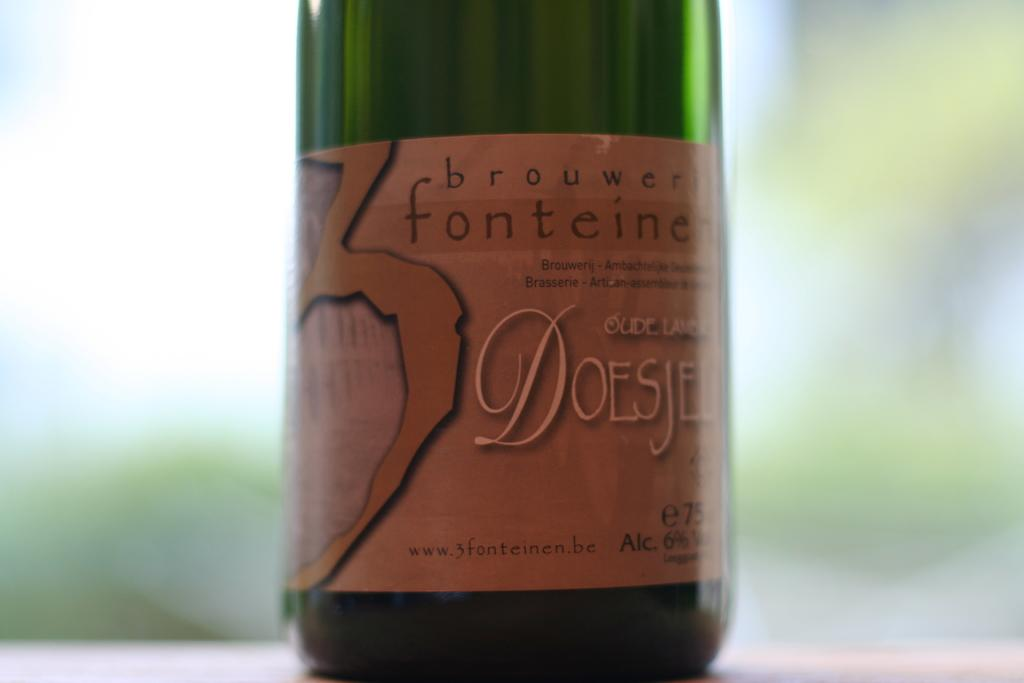<image>
Offer a succinct explanation of the picture presented. A green bottle of brouwer fonteine DOESJEL sitting on a table. 